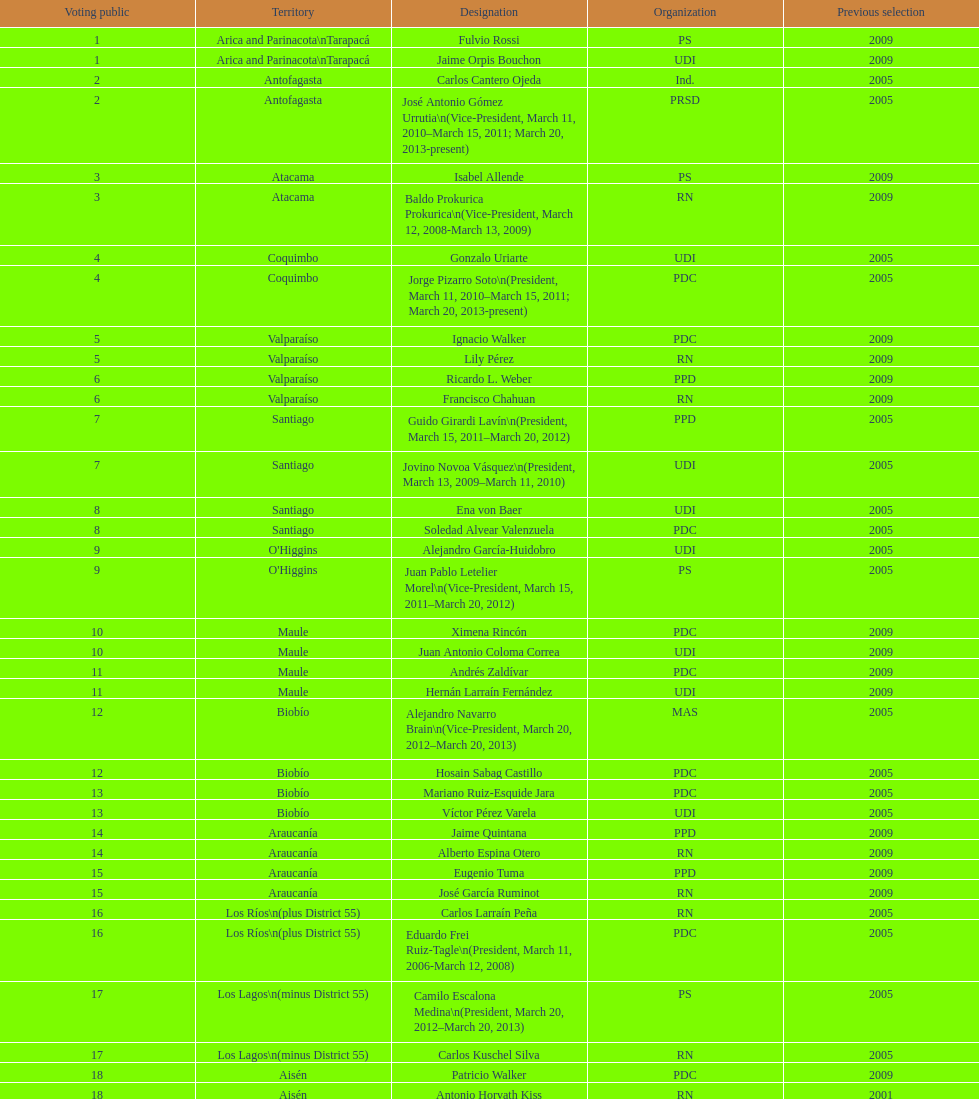What is the total number of constituencies? 19. 